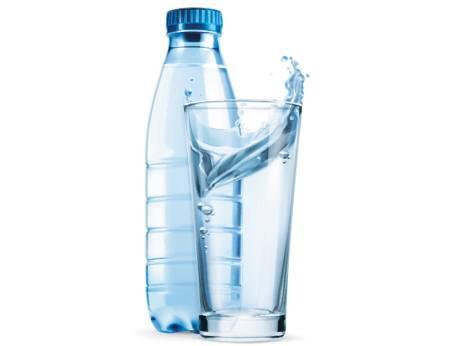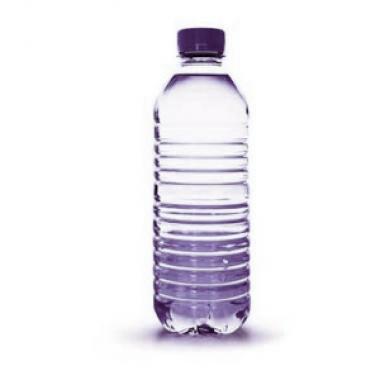The first image is the image on the left, the second image is the image on the right. Analyze the images presented: Is the assertion "There are three or more plastic water bottles in total." valid? Answer yes or no. No. The first image is the image on the left, the second image is the image on the right. Evaluate the accuracy of this statement regarding the images: "The combined images include an open-topped glass of water and no more than two plastic water bottles.". Is it true? Answer yes or no. Yes. 